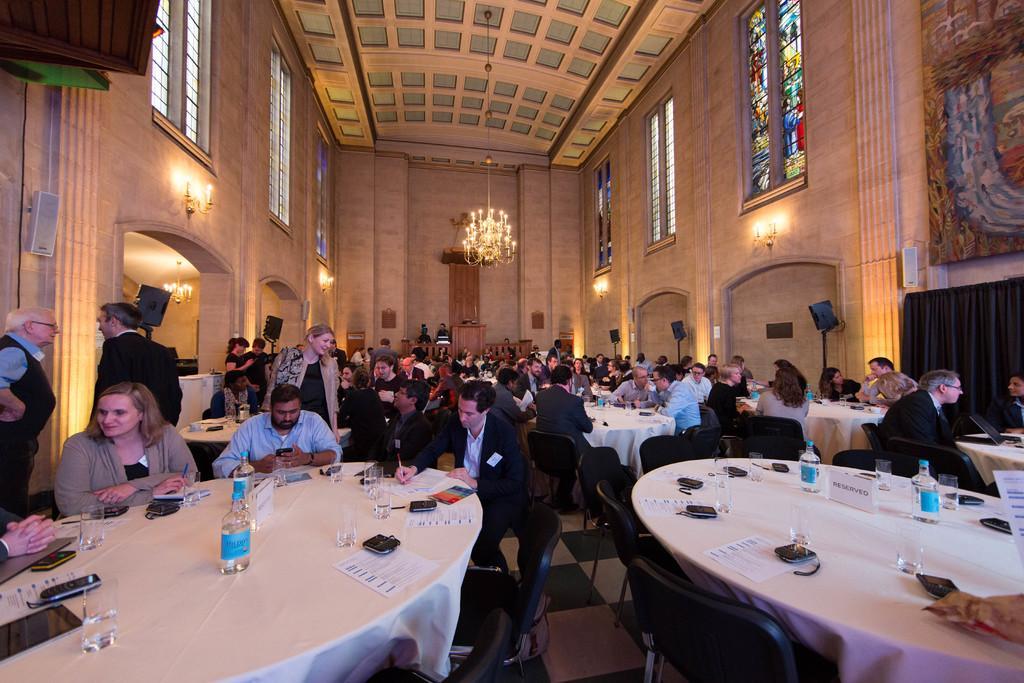Describe this image in one or two sentences. There is a group of people. Some people are sitting on a chair. Some people are standing. There is a table. There is a paper,bottle,ipad on a table. We can see the background lights,window. 